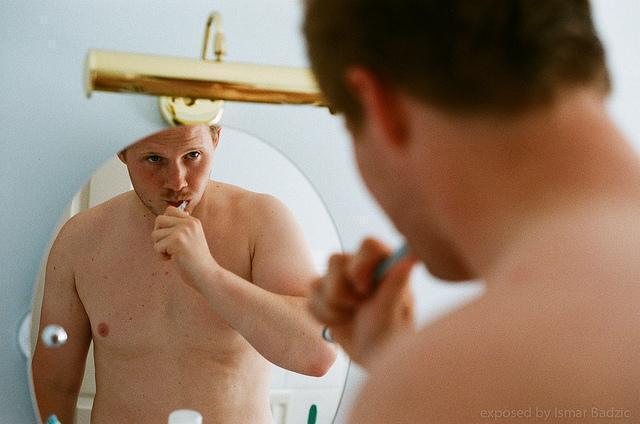What is this activity good for?
Select the correct answer and articulate reasoning with the following format: 'Answer: answer
Rationale: rationale.'
Options: Building muscles, nutrition, gum health, mental health. Answer: gum health.
Rationale: The activity is good for gum health. 